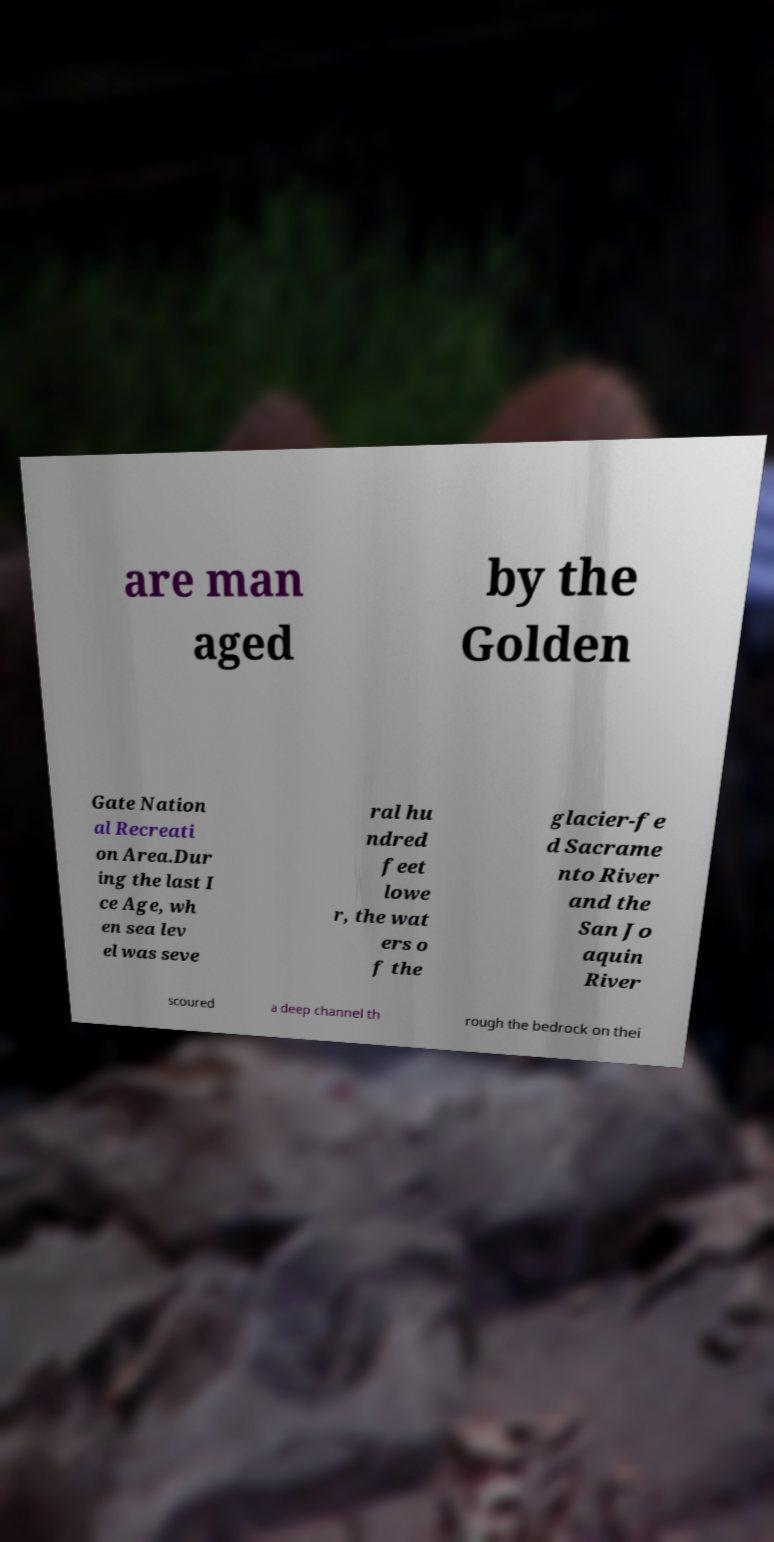Can you accurately transcribe the text from the provided image for me? are man aged by the Golden Gate Nation al Recreati on Area.Dur ing the last I ce Age, wh en sea lev el was seve ral hu ndred feet lowe r, the wat ers o f the glacier-fe d Sacrame nto River and the San Jo aquin River scoured a deep channel th rough the bedrock on thei 